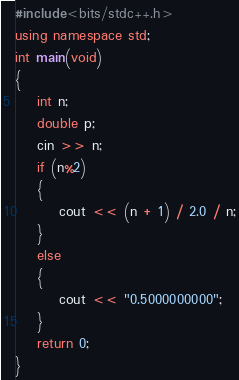Convert code to text. <code><loc_0><loc_0><loc_500><loc_500><_C++_>#include<bits/stdc++.h>
using namespace std;
int main(void)
{
	int n;
	double p;
	cin >> n;
	if (n%2)
	{
		cout << (n + 1) / 2.0 / n;
	}
	else
	{
		cout << "0.5000000000";
	}
	return 0;
}</code> 